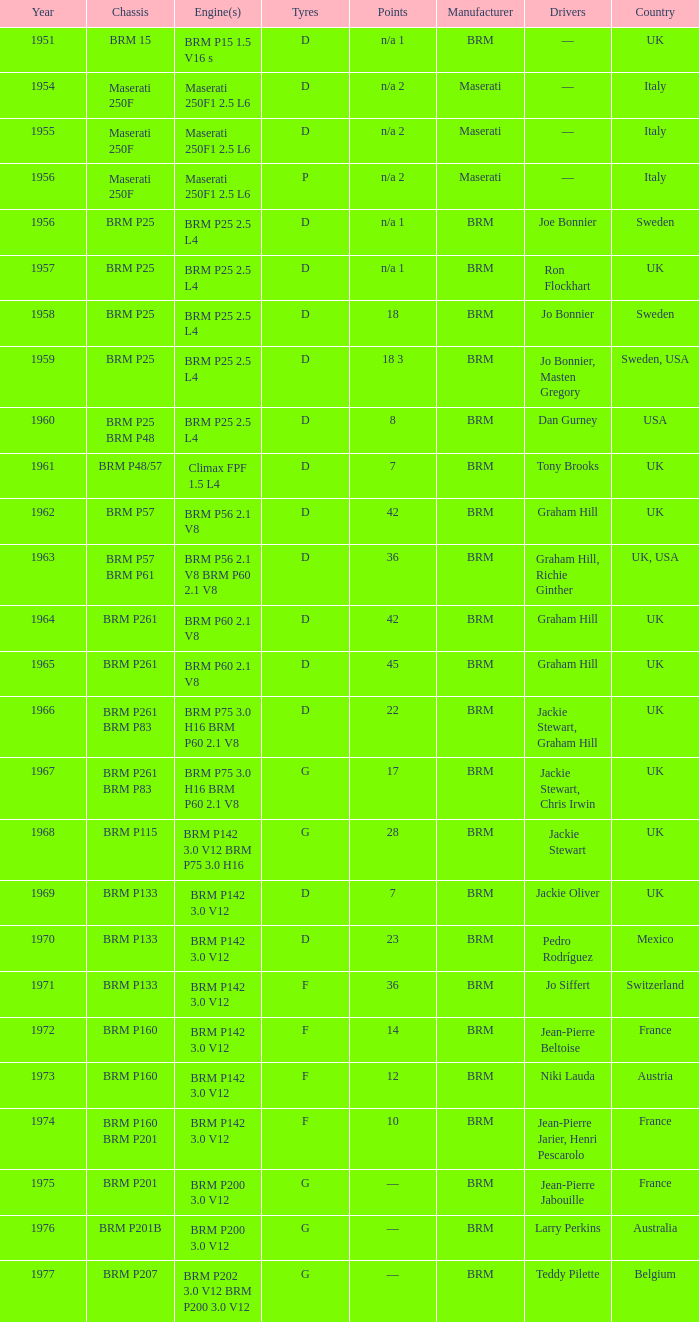Identify the framework of 1961 BRM P48/57. 